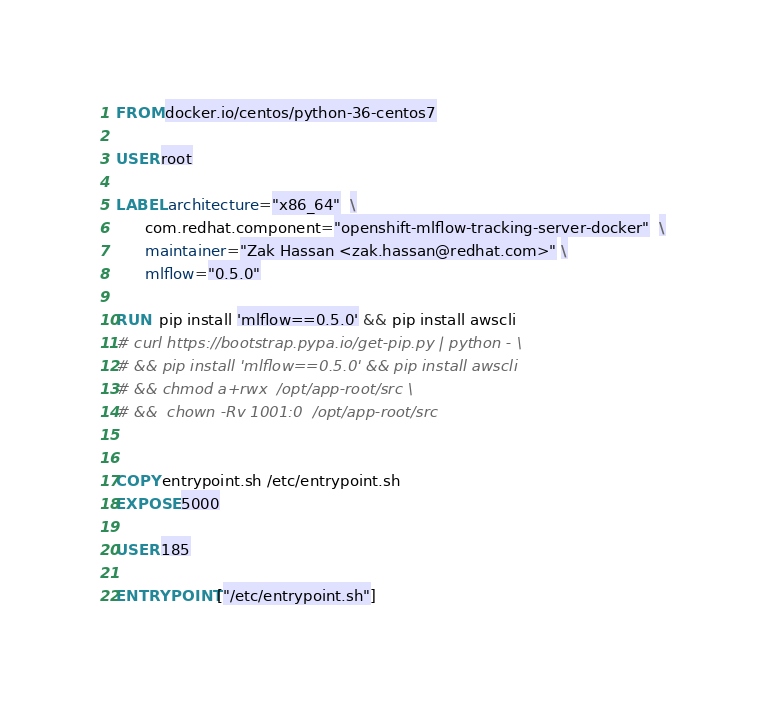<code> <loc_0><loc_0><loc_500><loc_500><_Dockerfile_>
FROM docker.io/centos/python-36-centos7

USER root

LABEL architecture="x86_64"  \
      com.redhat.component="openshift-mlflow-tracking-server-docker"  \
      maintainer="Zak Hassan <zak.hassan@redhat.com>" \
      mlflow="0.5.0"

RUN  pip install 'mlflow==0.5.0' && pip install awscli
# curl https://bootstrap.pypa.io/get-pip.py | python - \
# && pip install 'mlflow==0.5.0' && pip install awscli
# && chmod a+rwx  /opt/app-root/src \
# &&  chown -Rv 1001:0  /opt/app-root/src


COPY entrypoint.sh /etc/entrypoint.sh
EXPOSE 5000

USER 185

ENTRYPOINT ["/etc/entrypoint.sh"]
</code> 